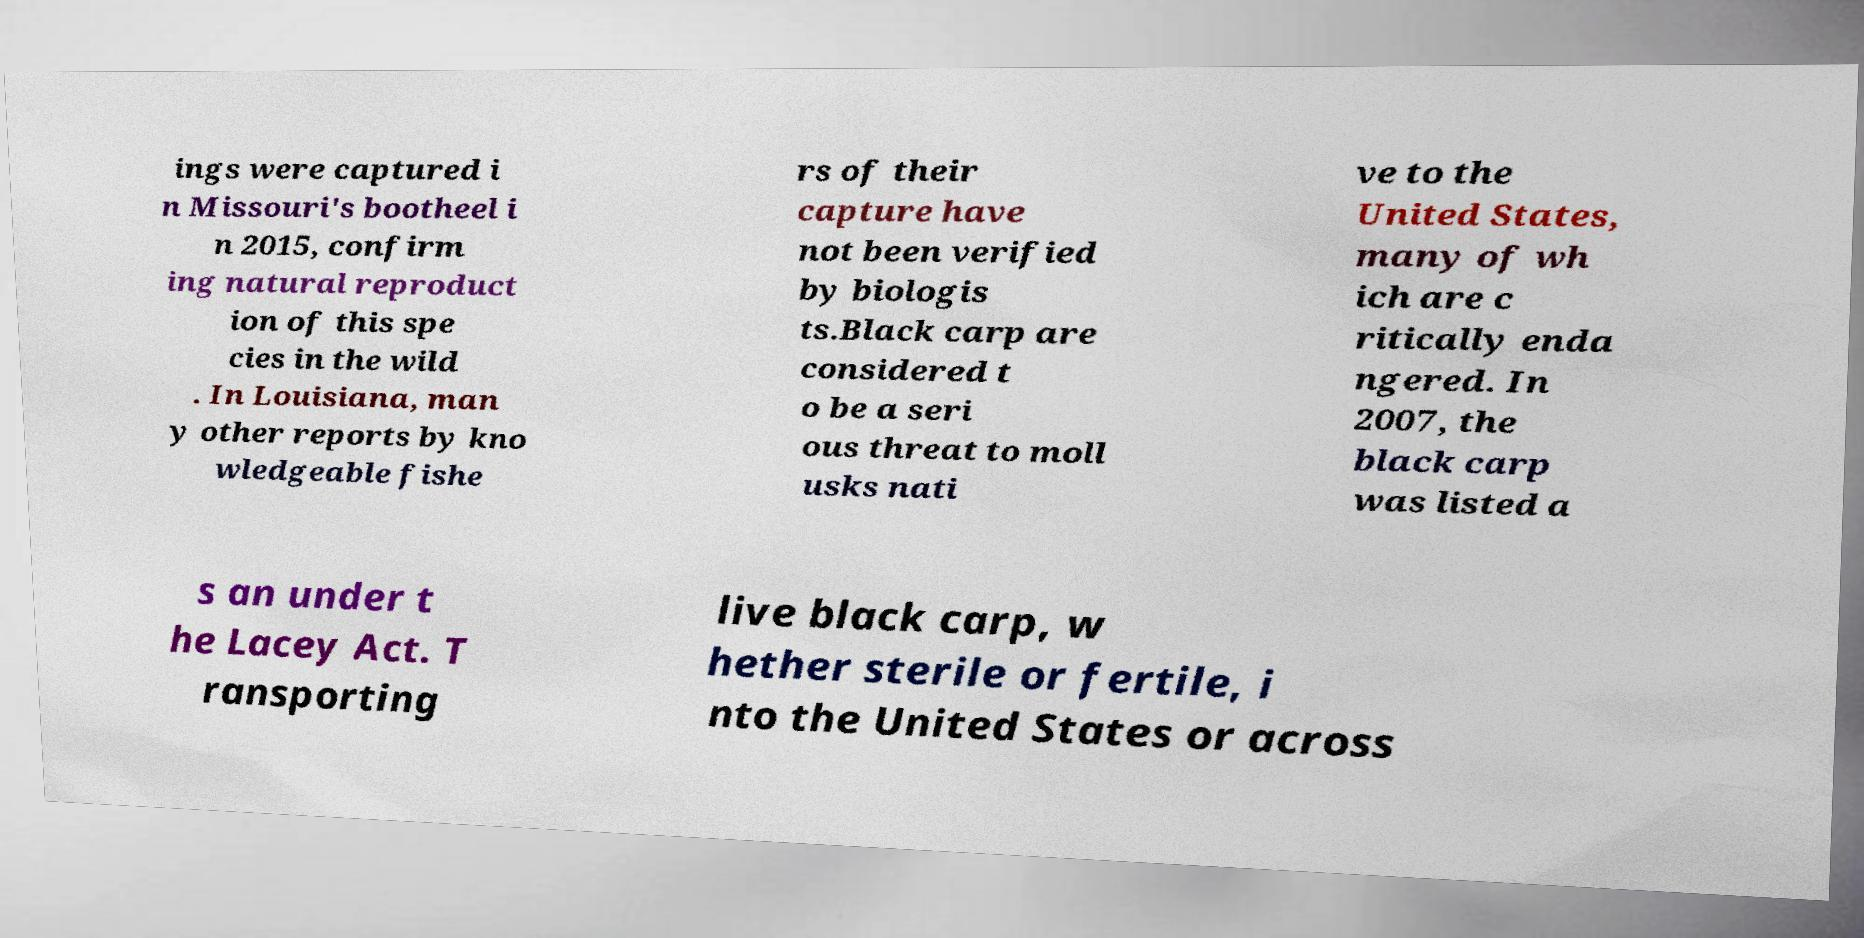There's text embedded in this image that I need extracted. Can you transcribe it verbatim? ings were captured i n Missouri's bootheel i n 2015, confirm ing natural reproduct ion of this spe cies in the wild . In Louisiana, man y other reports by kno wledgeable fishe rs of their capture have not been verified by biologis ts.Black carp are considered t o be a seri ous threat to moll usks nati ve to the United States, many of wh ich are c ritically enda ngered. In 2007, the black carp was listed a s an under t he Lacey Act. T ransporting live black carp, w hether sterile or fertile, i nto the United States or across 